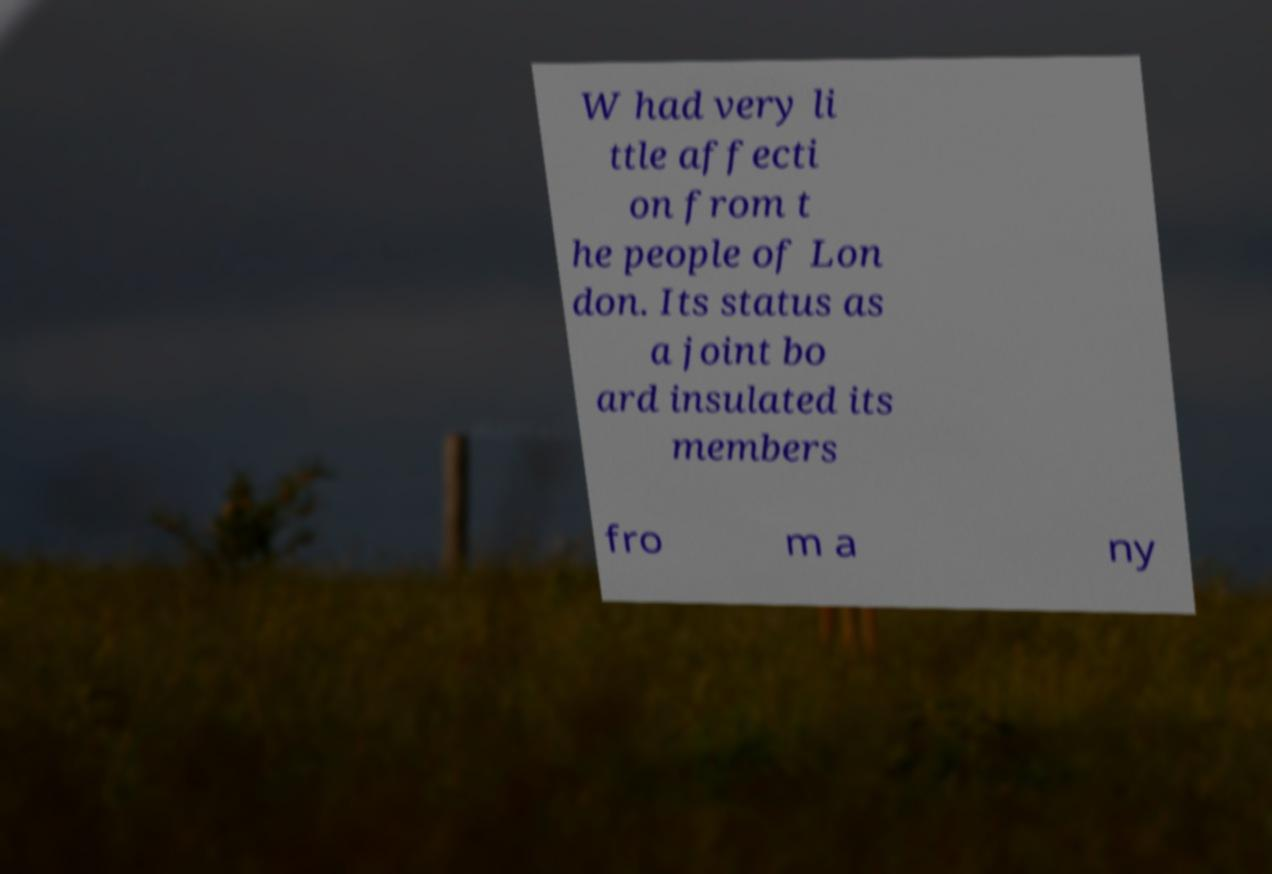Can you read and provide the text displayed in the image?This photo seems to have some interesting text. Can you extract and type it out for me? W had very li ttle affecti on from t he people of Lon don. Its status as a joint bo ard insulated its members fro m a ny 